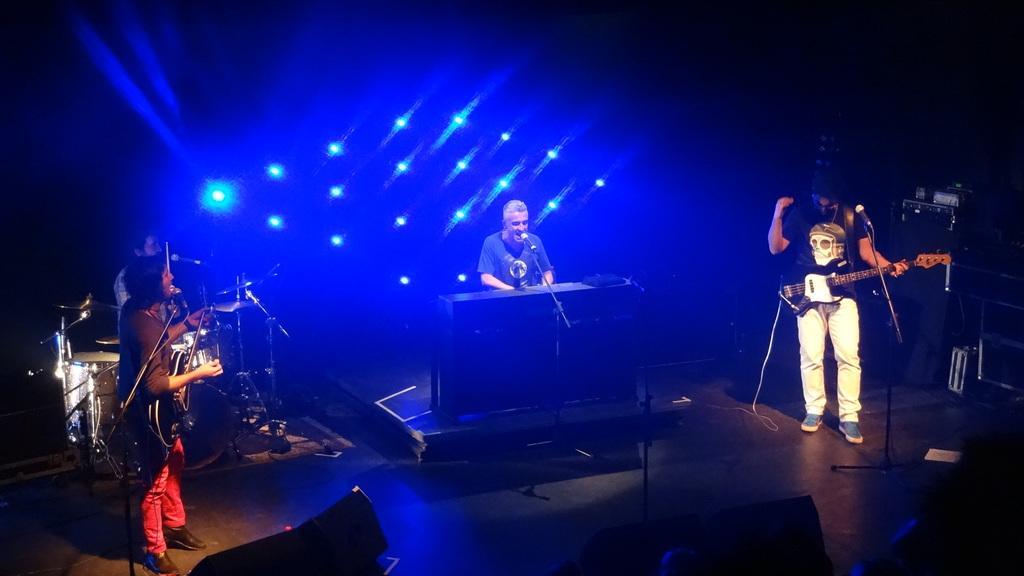In one or two sentences, can you explain what this image depicts? In the picture we can see a man sitting and playing a musical keyboard and singing a song in the microphone which is in the stand and on the both sides of him we can see the people playing a musical instrument and in the background we can see some blue color lights. 